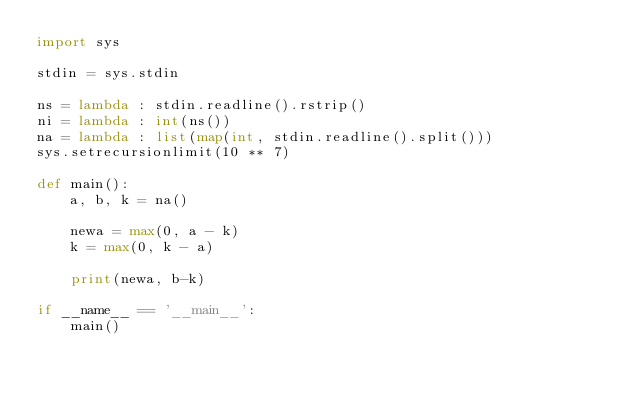<code> <loc_0><loc_0><loc_500><loc_500><_Python_>import sys

stdin = sys.stdin

ns = lambda : stdin.readline().rstrip()
ni = lambda : int(ns())
na = lambda : list(map(int, stdin.readline().split()))
sys.setrecursionlimit(10 ** 7)

def main():
    a, b, k = na()

    newa = max(0, a - k)
    k = max(0, k - a)
    
    print(newa, b-k)

if __name__ == '__main__':
    main()</code> 